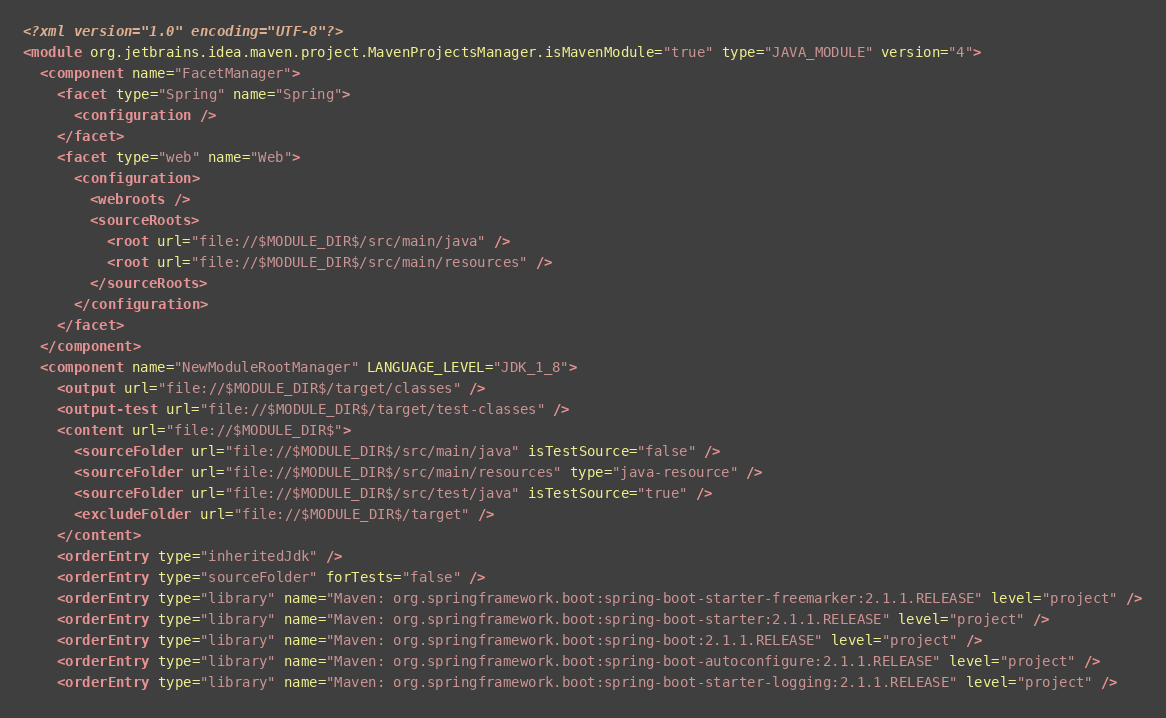<code> <loc_0><loc_0><loc_500><loc_500><_XML_><?xml version="1.0" encoding="UTF-8"?>
<module org.jetbrains.idea.maven.project.MavenProjectsManager.isMavenModule="true" type="JAVA_MODULE" version="4">
  <component name="FacetManager">
    <facet type="Spring" name="Spring">
      <configuration />
    </facet>
    <facet type="web" name="Web">
      <configuration>
        <webroots />
        <sourceRoots>
          <root url="file://$MODULE_DIR$/src/main/java" />
          <root url="file://$MODULE_DIR$/src/main/resources" />
        </sourceRoots>
      </configuration>
    </facet>
  </component>
  <component name="NewModuleRootManager" LANGUAGE_LEVEL="JDK_1_8">
    <output url="file://$MODULE_DIR$/target/classes" />
    <output-test url="file://$MODULE_DIR$/target/test-classes" />
    <content url="file://$MODULE_DIR$">
      <sourceFolder url="file://$MODULE_DIR$/src/main/java" isTestSource="false" />
      <sourceFolder url="file://$MODULE_DIR$/src/main/resources" type="java-resource" />
      <sourceFolder url="file://$MODULE_DIR$/src/test/java" isTestSource="true" />
      <excludeFolder url="file://$MODULE_DIR$/target" />
    </content>
    <orderEntry type="inheritedJdk" />
    <orderEntry type="sourceFolder" forTests="false" />
    <orderEntry type="library" name="Maven: org.springframework.boot:spring-boot-starter-freemarker:2.1.1.RELEASE" level="project" />
    <orderEntry type="library" name="Maven: org.springframework.boot:spring-boot-starter:2.1.1.RELEASE" level="project" />
    <orderEntry type="library" name="Maven: org.springframework.boot:spring-boot:2.1.1.RELEASE" level="project" />
    <orderEntry type="library" name="Maven: org.springframework.boot:spring-boot-autoconfigure:2.1.1.RELEASE" level="project" />
    <orderEntry type="library" name="Maven: org.springframework.boot:spring-boot-starter-logging:2.1.1.RELEASE" level="project" /></code> 